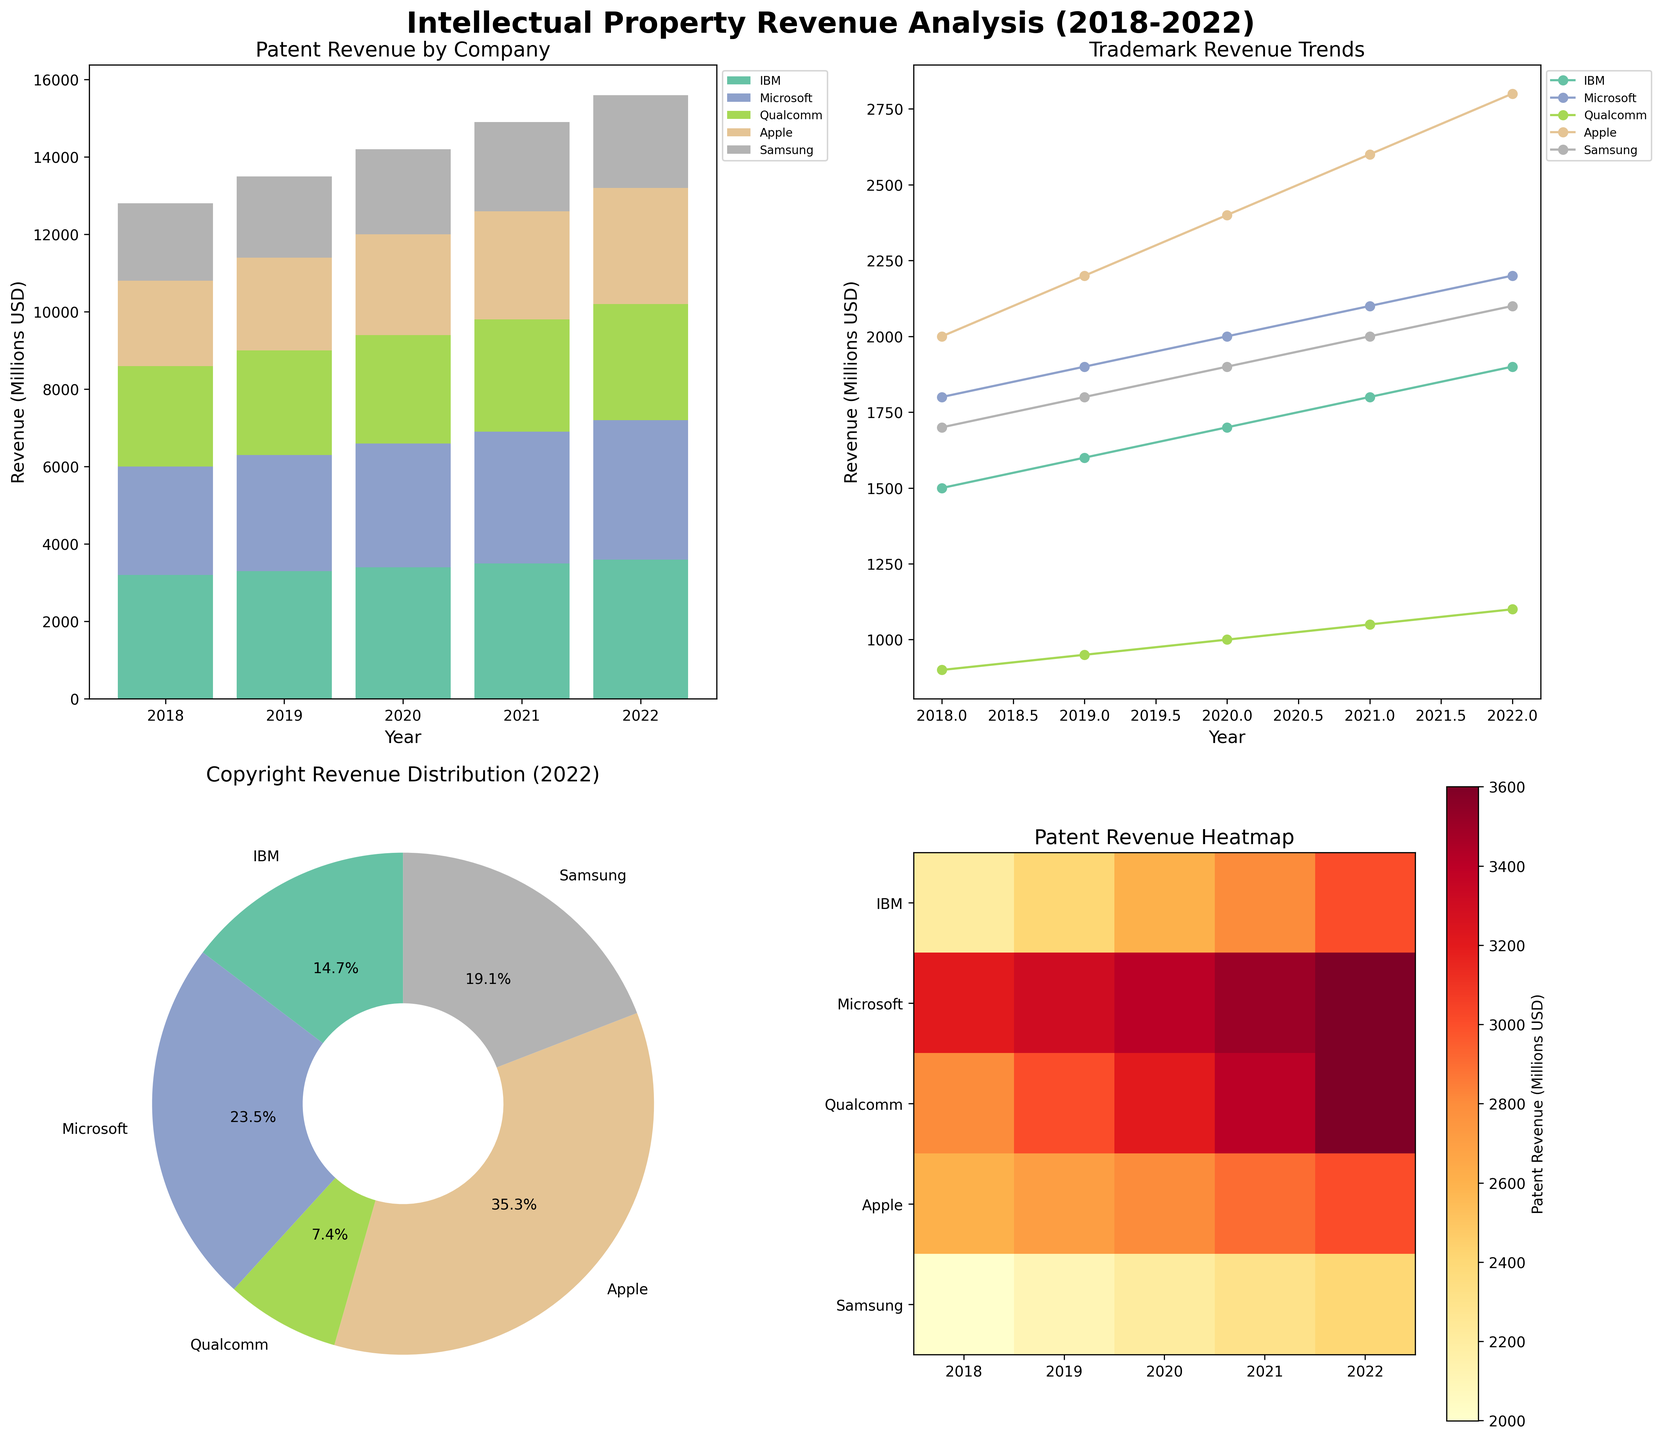What's the total patent revenue for IBM over the period 2018-2022? To find the total patent revenue for IBM, sum the values: 3200 (2018) + 3300 (2019) + 3400 (2020) + 3500 (2021) + 3600 (2022) = 17000
Answer: 17000 Which company had the highest trademark revenue in 2022? Looking at the line plot for trademark revenue, observe the highest point in 2022. Apple has the highest trademark revenue with a value of 2800
Answer: Apple How did Qualcomm's copyright revenue change from 2018 to 2022? From the pie chart and observed data, Qualcomm's copyright revenue increased from 300 in 2018 to 500 in 2022. The change is 500 - 300 = 200
Answer: Increased by 200 Which company appears to have the most stable patent revenue over the years? Evaluate the heatmap for consistency across years. Samsung shows the most consistent (less varied) patent revenue from 2000 in 2018 to 2400 in 2022
Answer: Samsung Compare the total intellectual property revenue (sum of patent, trademark, and copyright) for Apple and Microsoft in 2020. Sum Apple's revenue: 2600 (Patents) + 2400 (Trademarks) + 2000 (Copyrights) = 7000. Sum Microsoft's revenue: 3200 (Patents) + 2000 (Trademarks) + 1400 (Copyrights) = 6600. Apple has a higher total
Answer: Apple Which year had the highest combined patent revenue for all companies? Summing revenues for each year from the bar chart: 2018: 12800, 2019: 13500, 2020: 14000, 2021: 14900, 2022: 15600. 2022 has the highest combined revenue
Answer: 2022 What percentage of the total copyright revenue did Samsung account for in 2022? Sum the copyright revenue for 2022: 1000 (IBM) + 1600 (Microsoft) + 500 (Qualcomm) + 2400 (Apple) + 1300 (Samsung) = 6800. Samsung portion = (1300 / 6800) * 100 = 19.1%
Answer: 19.1% Does the heatmap suggest any trends in IBM's patent revenue over the years? The heatmap indicates a rising trend for IBM's patent revenue from 3200 in 2018 to 3600 in 2022, demonstrating an increase over time
Answer: Rising trend What is the difference in patent revenue for Qualcomm between 2018 and 2022? From the bar chart, Qualcomm's patent revenue in 2018 was 2600 and in 2022 it was 3000. The difference is 3000 - 2600 = 400
Answer: 400 Which company showed the largest increase in trademark revenue from 2018 to 2022? From the line plot, Apple’s trademark revenue increased from 2000 in 2018 to 2800 in 2022, an increase of 800, the largest among the companies
Answer: Apple 